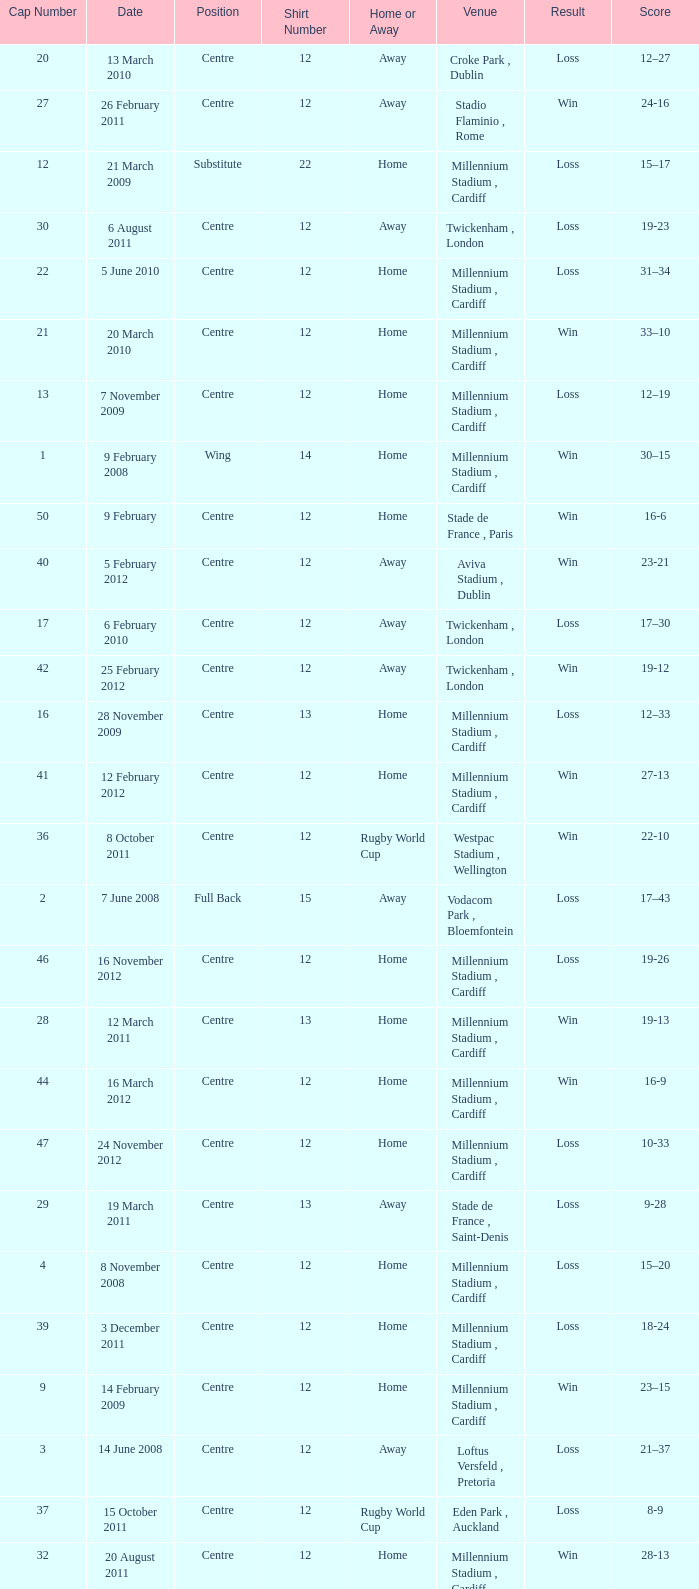Could you parse the entire table? {'header': ['Cap Number', 'Date', 'Position', 'Shirt Number', 'Home or Away', 'Venue', 'Result', 'Score'], 'rows': [['20', '13 March 2010', 'Centre', '12', 'Away', 'Croke Park , Dublin', 'Loss', '12–27'], ['27', '26 February 2011', 'Centre', '12', 'Away', 'Stadio Flaminio , Rome', 'Win', '24-16'], ['12', '21 March 2009', 'Substitute', '22', 'Home', 'Millennium Stadium , Cardiff', 'Loss', '15–17'], ['30', '6 August 2011', 'Centre', '12', 'Away', 'Twickenham , London', 'Loss', '19-23'], ['22', '5 June 2010', 'Centre', '12', 'Home', 'Millennium Stadium , Cardiff', 'Loss', '31–34'], ['21', '20 March 2010', 'Centre', '12', 'Home', 'Millennium Stadium , Cardiff', 'Win', '33–10'], ['13', '7 November 2009', 'Centre', '12', 'Home', 'Millennium Stadium , Cardiff', 'Loss', '12–19'], ['1', '9 February 2008', 'Wing', '14', 'Home', 'Millennium Stadium , Cardiff', 'Win', '30–15'], ['50', '9 February', 'Centre', '12', 'Home', 'Stade de France , Paris', 'Win', '16-6'], ['40', '5 February 2012', 'Centre', '12', 'Away', 'Aviva Stadium , Dublin', 'Win', '23-21'], ['17', '6 February 2010', 'Centre', '12', 'Away', 'Twickenham , London', 'Loss', '17–30'], ['42', '25 February 2012', 'Centre', '12', 'Away', 'Twickenham , London', 'Win', '19-12'], ['16', '28 November 2009', 'Centre', '13', 'Home', 'Millennium Stadium , Cardiff', 'Loss', '12–33'], ['41', '12 February 2012', 'Centre', '12', 'Home', 'Millennium Stadium , Cardiff', 'Win', '27-13'], ['36', '8 October 2011', 'Centre', '12', 'Rugby World Cup', 'Westpac Stadium , Wellington', 'Win', '22-10'], ['2', '7 June 2008', 'Full Back', '15', 'Away', 'Vodacom Park , Bloemfontein', 'Loss', '17–43'], ['46', '16 November 2012', 'Centre', '12', 'Home', 'Millennium Stadium , Cardiff', 'Loss', '19-26'], ['28', '12 March 2011', 'Centre', '13', 'Home', 'Millennium Stadium , Cardiff', 'Win', '19-13'], ['44', '16 March 2012', 'Centre', '12', 'Home', 'Millennium Stadium , Cardiff', 'Win', '16-9'], ['47', '24 November 2012', 'Centre', '12', 'Home', 'Millennium Stadium , Cardiff', 'Loss', '10-33'], ['29', '19 March 2011', 'Centre', '13', 'Away', 'Stade de France , Saint-Denis', 'Loss', '9-28'], ['4', '8 November 2008', 'Centre', '12', 'Home', 'Millennium Stadium , Cardiff', 'Loss', '15–20'], ['39', '3 December 2011', 'Centre', '12', 'Home', 'Millennium Stadium , Cardiff', 'Loss', '18-24'], ['9', '14 February 2009', 'Centre', '12', 'Home', 'Millennium Stadium , Cardiff', 'Win', '23–15'], ['3', '14 June 2008', 'Centre', '12', 'Away', 'Loftus Versfeld , Pretoria', 'Loss', '21–37'], ['37', '15 October 2011', 'Centre', '12', 'Rugby World Cup', 'Eden Park , Auckland', 'Loss', '8-9'], ['32', '20 August 2011', 'Centre', '12', 'Home', 'Millennium Stadium , Cardiff', 'Win', '28-13'], ['34', '18 September 2011', 'Centre', '12', 'Rugby World Cup', 'Waikato Stadium , Hamilton', 'Win', '17-10'], ['24', '26 June 2010', 'Centre', '12', 'Away', 'Waikato Stadium , Hamilton', 'Loss', '10–29'], ['38', '21 October 2011', 'Centre', '12', 'Rugby World Cup', 'Eden Park , Auckland', 'Loss', '18-21'], ['23', '19 June 2010', 'Centre', '12', 'Away', 'Carisbrook , Dunedin', 'Loss', '9–42'], ['45', '10 November 2012', 'Centre', '12', 'Home', 'Millennium Stadium , Cardiff', 'Loss', '12-26'], ['18', '13 February 2010', 'Centre', '12', 'Home', 'Millennium Stadium , Cardiff', 'Win', '31–24'], ['19', '26 February 2010', 'Centre', '12', 'Home', 'Millennium Stadium , Cardiff', 'Loss', '20–26'], ['31', '13 August 2011', 'Centre', '13', 'Home', 'Millennium Stadium , Cardiff', 'Win', '19-9'], ['8', '8 February 2009', 'Centre', '12', 'Away', 'Murrayfield , Edinburgh', 'Win', '26–13'], ['33', '11 September 2011', 'Centre', '12', 'Rugby World Cup', 'Westpac Stadium , Wellington', 'Loss', '16-17'], ['6', '22 November 2008', 'Centre', '12', 'Home', 'Millennium Stadium , Cardiff', 'Loss', '9–29'], ['49', '2 February', 'Centre', '12', 'Home', 'Millennium Stadium , Cardiff', 'Loss', '22-30'], ['7', '29 November 2008', 'Centre', '12', 'Home', 'Millennium Stadium , Cardiff', 'Win', '21–18'], ['5', '14 November 2008', 'Substitute', '22', 'Away', 'Millennium Stadium , Cardiff', 'Win', '34–13'], ['26', '12 February 2011', 'Centre', '13', 'Away', 'Murrayfield , Edinburgh', 'Win', '24-6'], ['43', '9 March 2012', 'Centre', '12', 'Home', 'Millennium Stadium , Cardiff', 'Win', '24-3'], ['11', '14 March 2009', 'Centre', '13', 'Away', 'Stadio Flaminio , Rome', 'Win', '20–15'], ['35', '2 September 2011', 'Centre', '12', 'Rugby World Cup', 'Waikato Stadium , Hamilton', 'Win', '66-0'], ['25', '4 February 2011', 'Centre', '13', 'Home', 'Millennium Stadium , Cardiff', 'Loss', '19–26'], ['14', '13 November 2009', 'Centre', '12', 'Home', 'Millennium Stadium , Cardiff', 'Win', '17–13'], ['10', '27 February 2009', 'Centre', '12', 'Away', 'Stade de France , Saint-Denis', 'Loss', '15–21'], ['15', '21 November 2009', 'Centre', '13', 'Home', 'Millennium Stadium , Cardiff', 'Win', '33–17'], ['48', '1 December 2012', 'Centre', '12', 'Home', 'Millennium Stadium , Cardiff', 'Loss', '12-14']]} What's the largest shirt number when the cap number is 5? 22.0. 